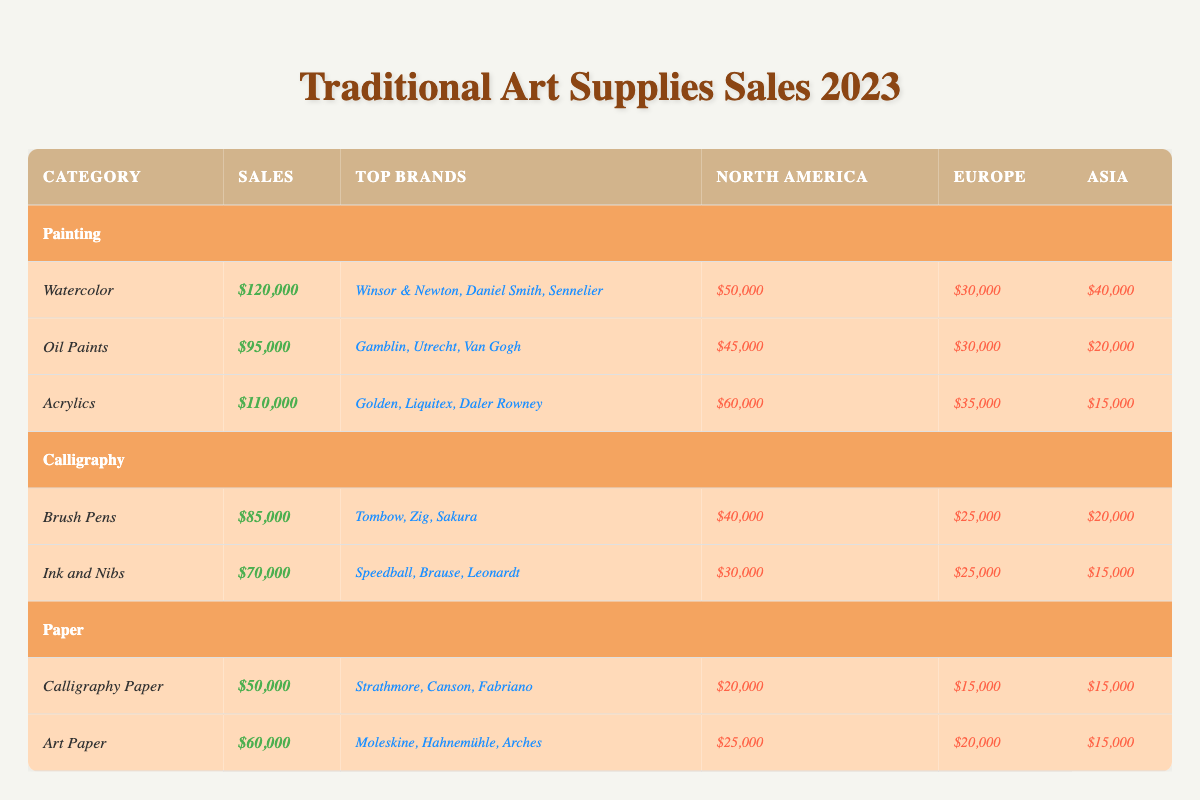What is the total sales for the Painting category? To find the total sales for the Painting category, we sum the sales of Watercolor, Oil Paints, and Acrylics. The sales are: 120000 + 95000 + 110000 = 325000.
Answer: 325000 Which region had the highest sales for Brush Pens? By examining the sales by region for Brush Pens, we see that North America has sales of 40000, Europe has 25000, and Asia has 20000, making North America the region with the highest sales.
Answer: North America How much more did Watercolor sales exceed Ink and Nibs sales? To find the difference between Watercolor sales and Ink and Nibs sales, we need to subtract the sales of Ink and Nibs (70000) from Watercolor sales (120000). So, 120000 - 70000 = 50000.
Answer: 50000 Is it true that the total sales for Paper items is greater than the total sales for Calligraphy items? We first calculate the total sales for Paper, which includes Calligraphy Paper (50000) and Art Paper (60000), giving us 50000 + 60000 = 110000. The total sales for Calligraphy, which includes Brush Pens (85000) and Ink and Nibs (70000), is 85000 + 70000 = 155000. Since 110000 is less than 155000, the statement is false.
Answer: No What is the average sales for the three subcategories under Painting? To find the average sales, first sum the sales of the three subcategories: 120000 (Watercolor) + 95000 (Oil Paints) + 110000 (Acrylics) = 325000. Then divide by 3 (the number of subcategories): 325000 / 3 ≈ 108333.33.
Answer: 108333.33 Which traditional art supply category generated the highest sales? We compare the total sales of all categories: Painting (325000), Calligraphy (155000), and Paper (110000). Painting has the highest sales with 325000.
Answer: Painting How many total sales were generated by the top brand in Oil Paints and Acrylics combined? The top brand for Oil Paints (Gamblin) does not have sales data listed, but we can assume it's within the Oil Paints total of 95000. The total sales for Acrylics is 110000. Thus, we add the two totals: 95000 + 110000 = 205000.
Answer: 205000 What sales amount corresponds to the lowest selling item in the Calligraphy category? In the Calligraphy category, Brush Pens sold 85000 while Ink and Nibs sold 70000. Ink and Nibs has the lower sales of 70000.
Answer: 70000 Which Asian region generated the most sales for Art Paper? From the sales data for Art Paper, we see that the sales figures for the regions are: North America 25000, Europe 20000, and Asia 15000, thus, North America generated the highest sales for Art Paper.
Answer: North America 